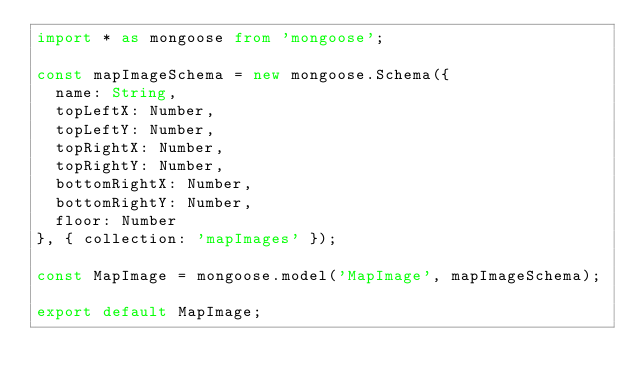Convert code to text. <code><loc_0><loc_0><loc_500><loc_500><_TypeScript_>import * as mongoose from 'mongoose';

const mapImageSchema = new mongoose.Schema({
	name: String,
	topLeftX: Number,
	topLeftY: Number,
	topRightX: Number,
	topRightY: Number,
	bottomRightX: Number,
	bottomRightY: Number,
	floor: Number
}, { collection: 'mapImages' });

const MapImage = mongoose.model('MapImage', mapImageSchema);

export default MapImage;
</code> 